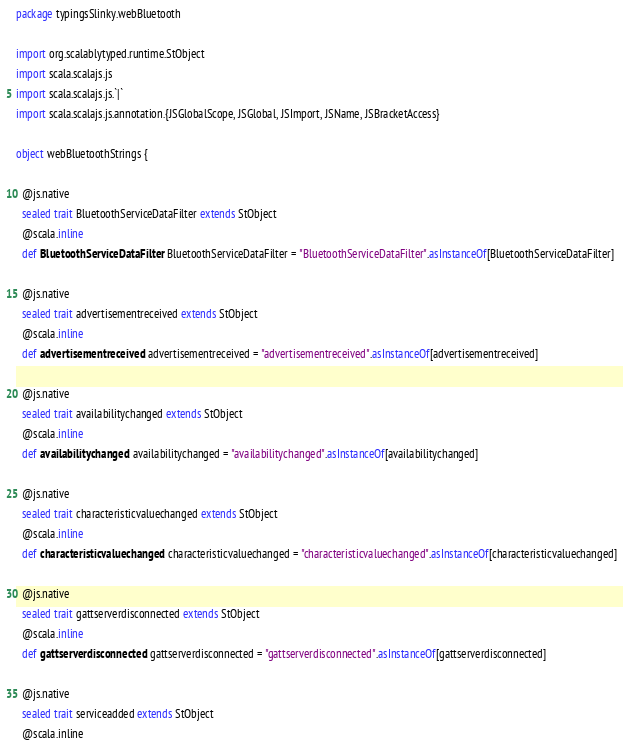Convert code to text. <code><loc_0><loc_0><loc_500><loc_500><_Scala_>package typingsSlinky.webBluetooth

import org.scalablytyped.runtime.StObject
import scala.scalajs.js
import scala.scalajs.js.`|`
import scala.scalajs.js.annotation.{JSGlobalScope, JSGlobal, JSImport, JSName, JSBracketAccess}

object webBluetoothStrings {
  
  @js.native
  sealed trait BluetoothServiceDataFilter extends StObject
  @scala.inline
  def BluetoothServiceDataFilter: BluetoothServiceDataFilter = "BluetoothServiceDataFilter".asInstanceOf[BluetoothServiceDataFilter]
  
  @js.native
  sealed trait advertisementreceived extends StObject
  @scala.inline
  def advertisementreceived: advertisementreceived = "advertisementreceived".asInstanceOf[advertisementreceived]
  
  @js.native
  sealed trait availabilitychanged extends StObject
  @scala.inline
  def availabilitychanged: availabilitychanged = "availabilitychanged".asInstanceOf[availabilitychanged]
  
  @js.native
  sealed trait characteristicvaluechanged extends StObject
  @scala.inline
  def characteristicvaluechanged: characteristicvaluechanged = "characteristicvaluechanged".asInstanceOf[characteristicvaluechanged]
  
  @js.native
  sealed trait gattserverdisconnected extends StObject
  @scala.inline
  def gattserverdisconnected: gattserverdisconnected = "gattserverdisconnected".asInstanceOf[gattserverdisconnected]
  
  @js.native
  sealed trait serviceadded extends StObject
  @scala.inline</code> 